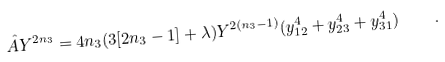<formula> <loc_0><loc_0><loc_500><loc_500>\hat { A } Y ^ { 2 n _ { 3 } } = 4 n _ { 3 } ( 3 [ 2 n _ { 3 } - 1 ] + \lambda ) Y ^ { 2 ( n _ { 3 } - 1 ) } ( y _ { 1 2 } ^ { 4 } + y _ { 2 3 } ^ { 4 } + y _ { 3 1 } ^ { 4 } ) \quad .</formula> 